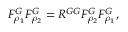Convert formula to latex. <formula><loc_0><loc_0><loc_500><loc_500>F _ { \rho _ { 1 } } ^ { G } F _ { \rho _ { 2 } } ^ { G } = R ^ { G G } F _ { \rho _ { 2 } } ^ { G } F _ { \rho _ { 1 } } ^ { G } ,</formula> 